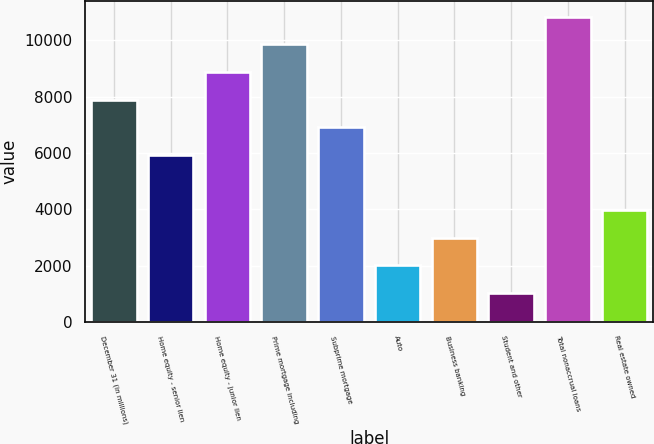<chart> <loc_0><loc_0><loc_500><loc_500><bar_chart><fcel>December 31 (in millions)<fcel>Home equity - senior lien<fcel>Home equity - junior lien<fcel>Prime mortgage including<fcel>Subprime mortgage<fcel>Auto<fcel>Business banking<fcel>Student and other<fcel>Total nonaccrual loans<fcel>Real estate owned<nl><fcel>7893.8<fcel>5929.6<fcel>8875.9<fcel>9858<fcel>6911.7<fcel>2001.2<fcel>2983.3<fcel>1019.1<fcel>10840.1<fcel>3965.4<nl></chart> 